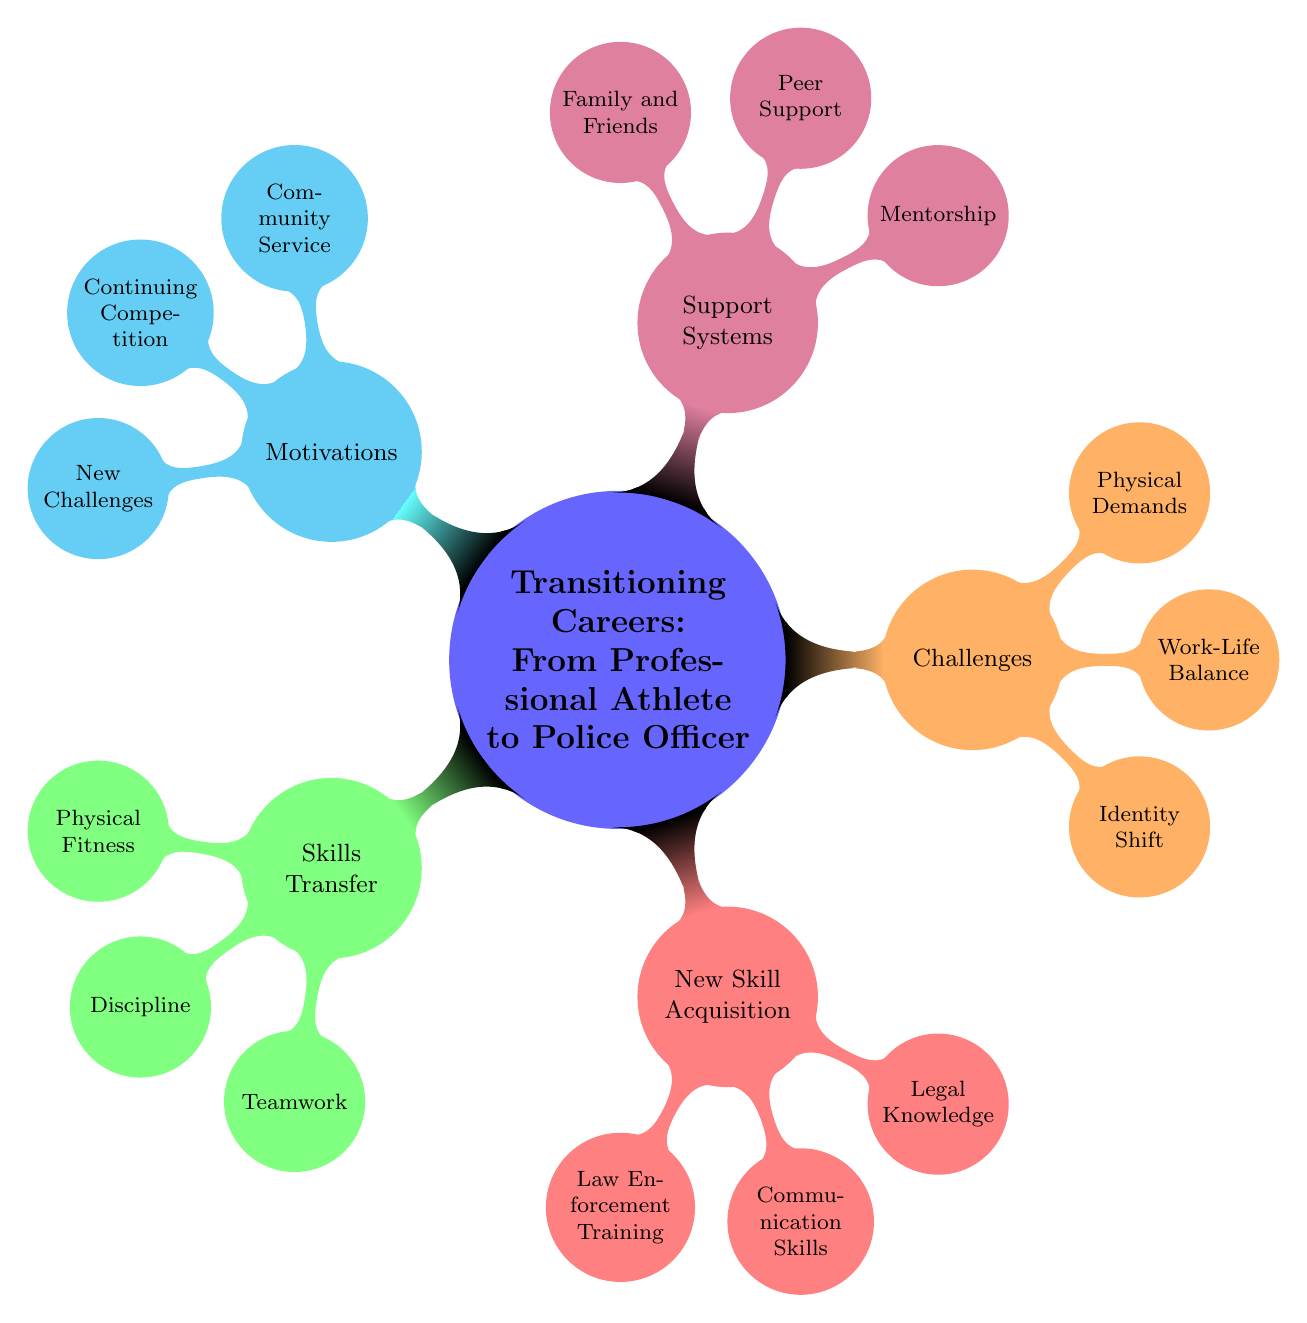How many main branches are there in the diagram? The diagram has five main branches, representing different aspects of transitioning careers from a professional athlete to a police officer. The main branches are Skills Transfer, New Skill Acquisition, Challenges, Support Systems, and Motivations.
Answer: 5 What is one skill acquired under New Skill Acquisition? The skill "Law Enforcement Training" is one of the skills acquired under the New Skill Acquisition branch, indicating the importance of formal training in law enforcement as part of the career transition.
Answer: Law Enforcement Training Which motivation relates to your involvement in sports leagues? The motivation "Continuing Competition" directly relates to involvement in sports leagues, linking the competitive nature of police sports leagues to the former professional athlete's desire to remain engaged in competition.
Answer: Continuing Competition What challenge involves personal life management? The challenge "Work-Life Balance" specifically relates to managing personal life alongside the demanding schedule that comes with being a police officer, highlighting the importance of balancing work and personal commitments.
Answer: Work-Life Balance What does the Skills Transfer branch emphasize? The Skills Transfer branch emphasizes the application of existing skills gained from being a professional athlete, specifically highlighting Physical Fitness, Discipline, and Teamwork as transferable skills to law enforcement.
Answer: Physical Fitness How does mentorship function in the context of this career transition? Mentorship is critical as it provides guidance from experienced police officers, which helps former athletes navigate their new roles and responsibilities effectively, thus aiding in a smoother transition.
Answer: Guidance from experienced police officers 